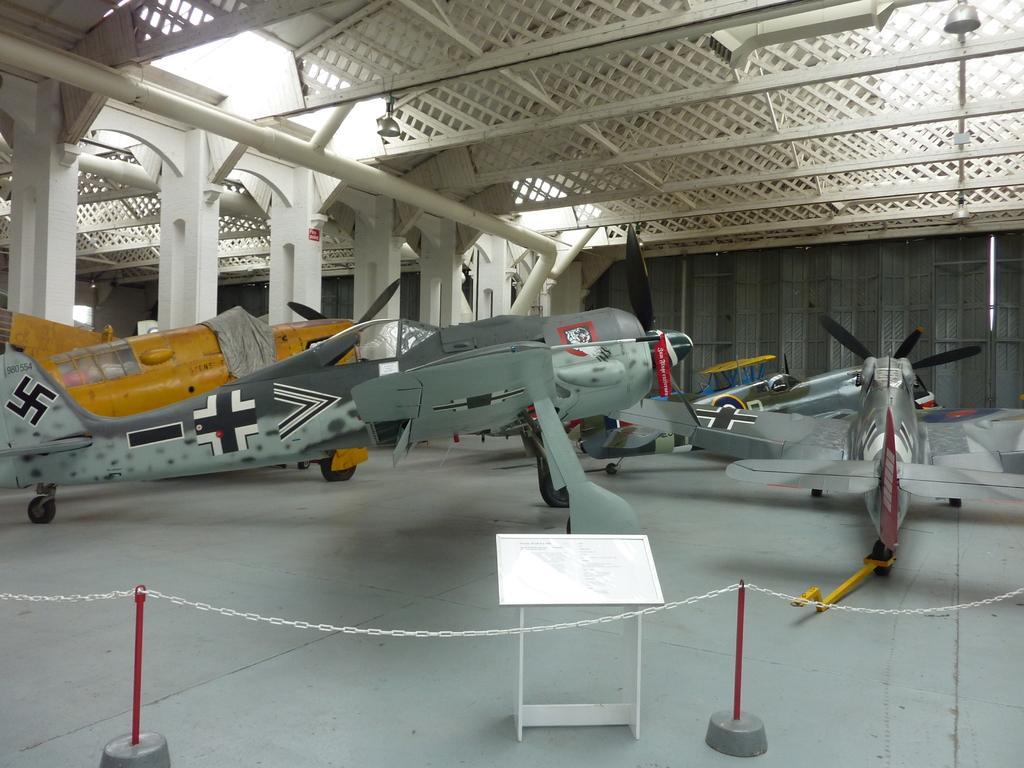Can you describe this image briefly? In this image, we can see few aircraft on the path. At the bottom of the image, we can see desk and rods with chain. In the background, there are pillars, rods, pipes, shed and few objects. 